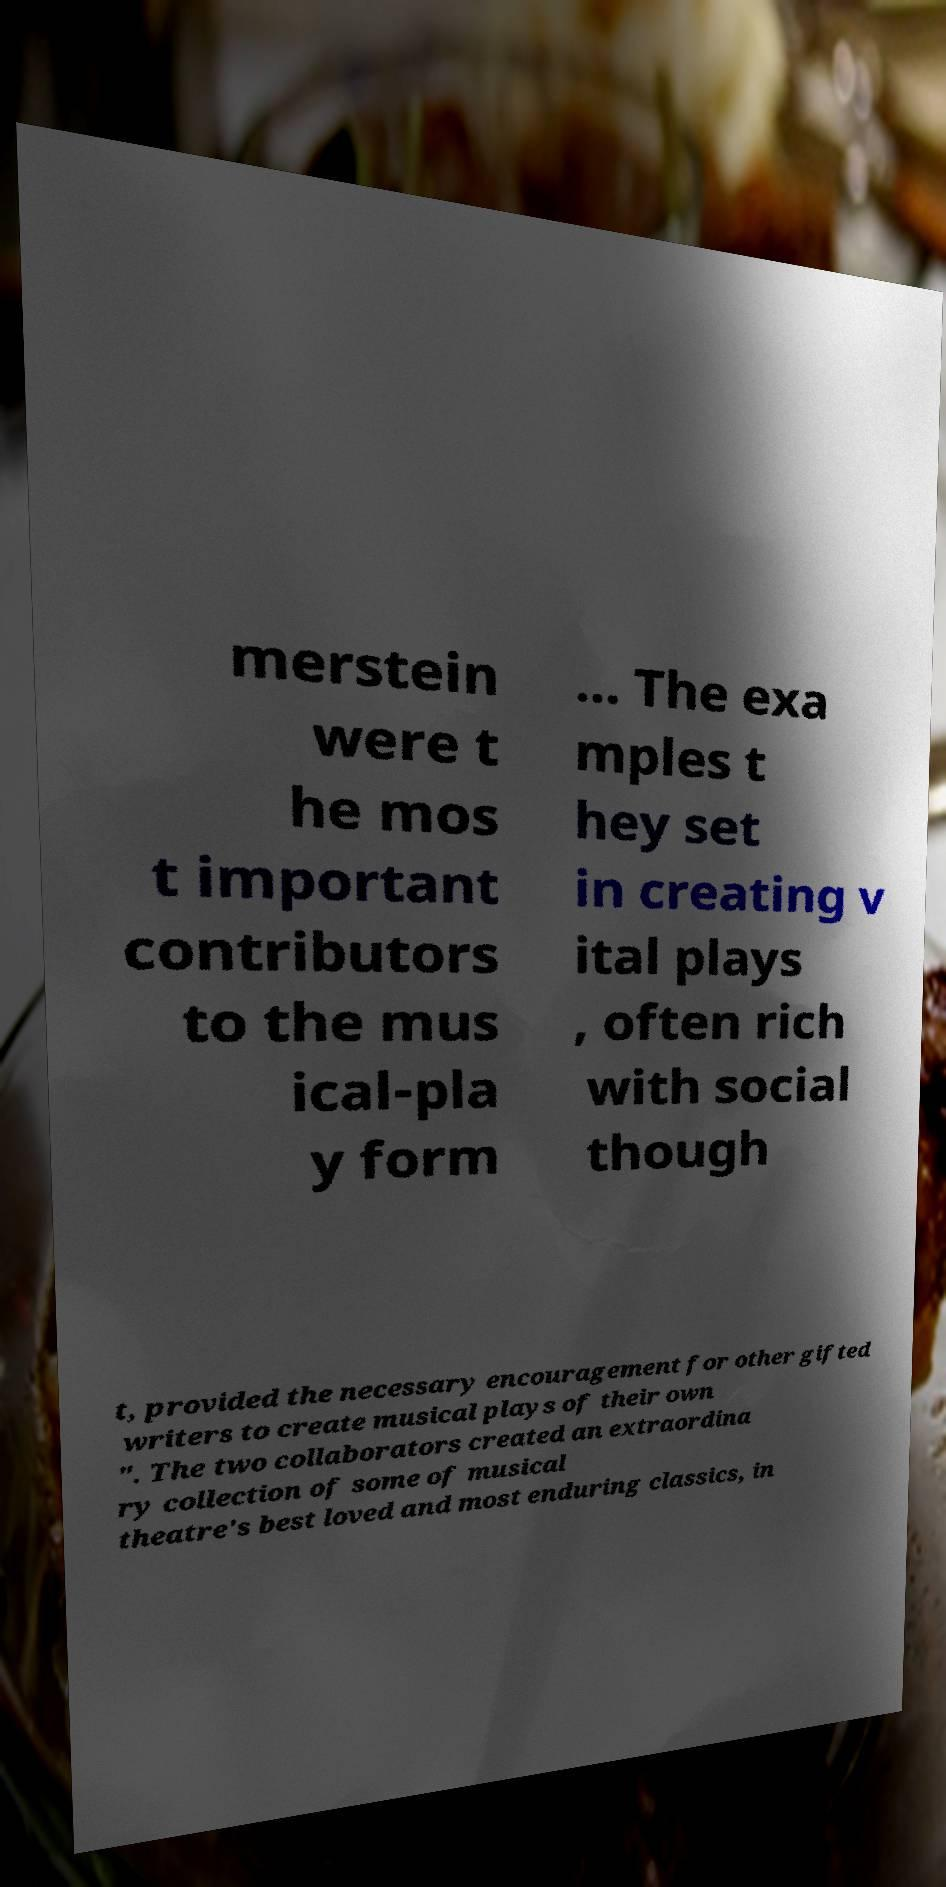Please identify and transcribe the text found in this image. merstein were t he mos t important contributors to the mus ical-pla y form ... The exa mples t hey set in creating v ital plays , often rich with social though t, provided the necessary encouragement for other gifted writers to create musical plays of their own ". The two collaborators created an extraordina ry collection of some of musical theatre's best loved and most enduring classics, in 